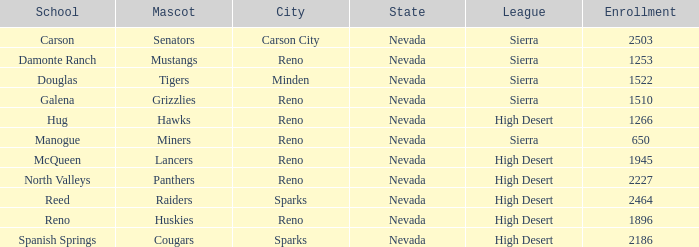Which leagues have Raiders as their mascot? High Desert. 